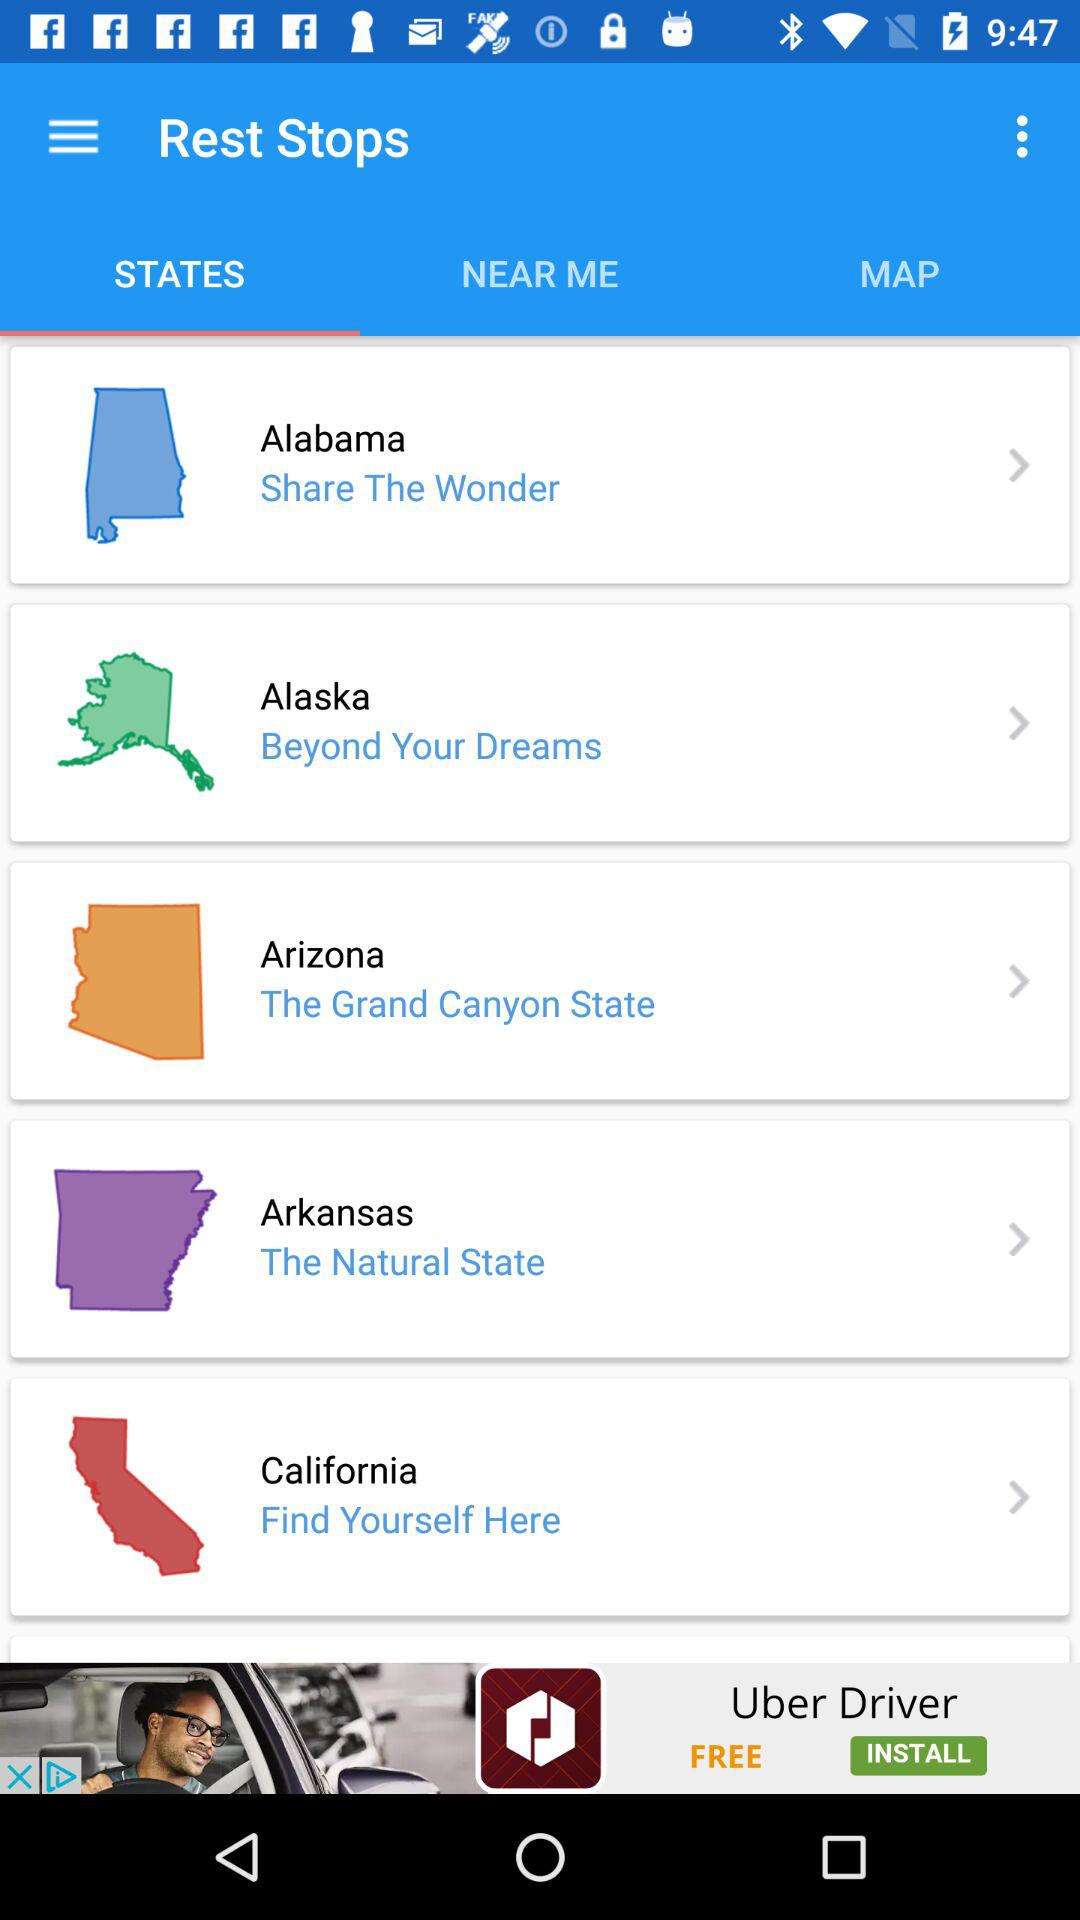What are the different states? The different states are Alabama, Alaska, Arizona, Arkansas and California. 